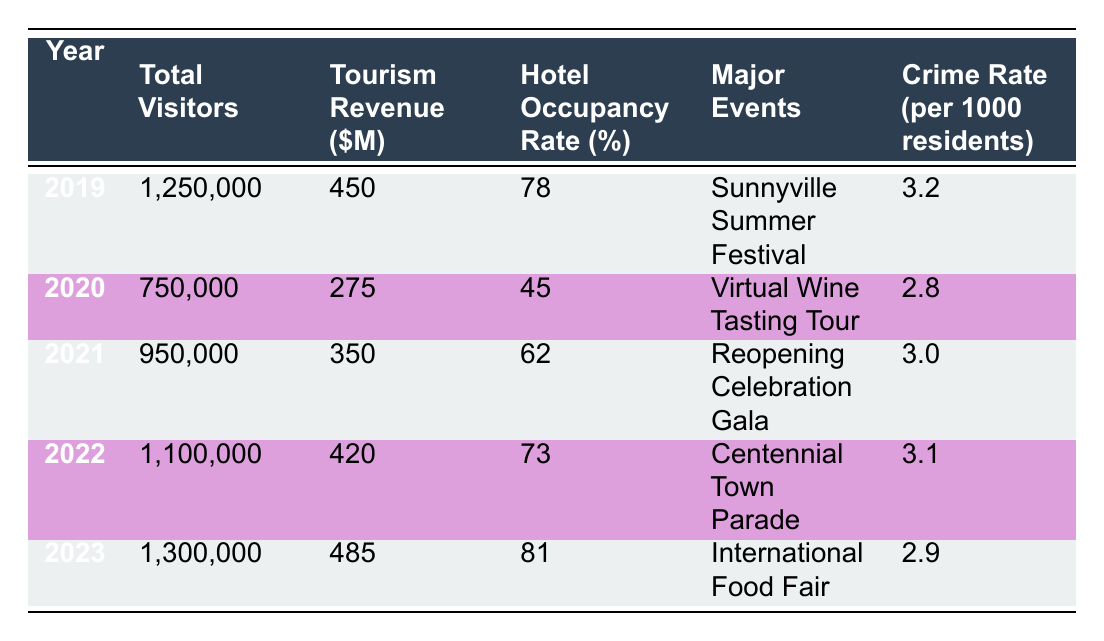What year had the highest tourism revenue? From the table, looking at the "Tourism Revenue ($M)" column, the highest value is 485, which corresponds to the year 2023.
Answer: 2023 What was the hotel occupancy rate in 2020? Directly reference the "Hotel Occupancy Rate (%)" column for the year 2020, which shows a rate of 45%.
Answer: 45 How many total visitors were there in 2021? By reading the "Total Visitors" column for the year 2021, we find a value of 950,000.
Answer: 950,000 What is the average tourism revenue over the past 5 years? Adding the revenues: 450 + 275 + 350 + 420 + 485 = 2280. The average is 2280/5 = 456.
Answer: 456 Did the crime rate increase or decrease from 2019 to 2022? Comparing the "Crime Rate (per 1000 residents)" from 2019 (3.2) to 2022 (3.1), it decreased.
Answer: Decreased What event took place in 2022? The table specifies that the major event in 2022 was the "Centennial Town Parade."
Answer: Centennial Town Parade What year had the lowest total visitors? By checking the "Total Visitors" column, 2020 has the lowest number at 750,000.
Answer: 2020 What was the change in hotel occupancy from 2022 to 2023? For 2022, the occupancy rate was 73%, and for 2023 it was 81%, leading to a change of 81 - 73 = 8%.
Answer: 8% What was the average crime rate across all years? The crime rates are 3.2, 2.8, 3.0, 3.1, and 2.9. Adding these gives 15. The average is 15/5 = 3.
Answer: 3 Which year saw the most visitors and what event was held? The year with the most visitors is 2023 with 1,300,000 visitors, and the event was the "International Food Fair."
Answer: 2023, International Food Fair 